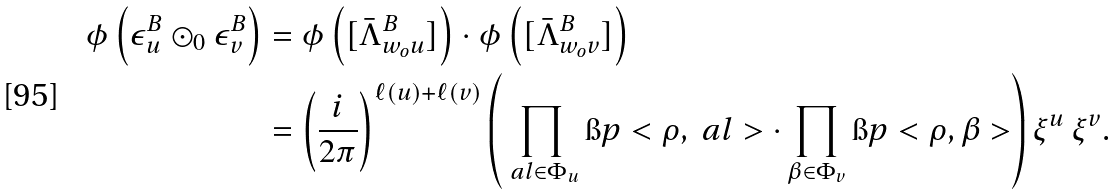<formula> <loc_0><loc_0><loc_500><loc_500>\phi \left ( \epsilon _ { u } ^ { B } \odot _ { 0 } \epsilon _ { v } ^ { B } \right ) & = \phi \left ( [ \bar { \Lambda } ^ { B } _ { w _ { o } u } ] \right ) \cdot \phi \left ( [ \bar { \Lambda } ^ { B } _ { w _ { o } v } ] \right ) \\ & = \left ( \frac { i } { 2 \pi } \right ) ^ { \ell ( u ) + \ell ( v ) } \left ( \prod _ { \ a l \in \Phi _ { u } } \i p < \rho , \ a l > \cdot \prod _ { \beta \in \Phi _ { v } } \i p < \rho , \beta > \right ) \xi ^ { u } \, \xi ^ { v } .</formula> 